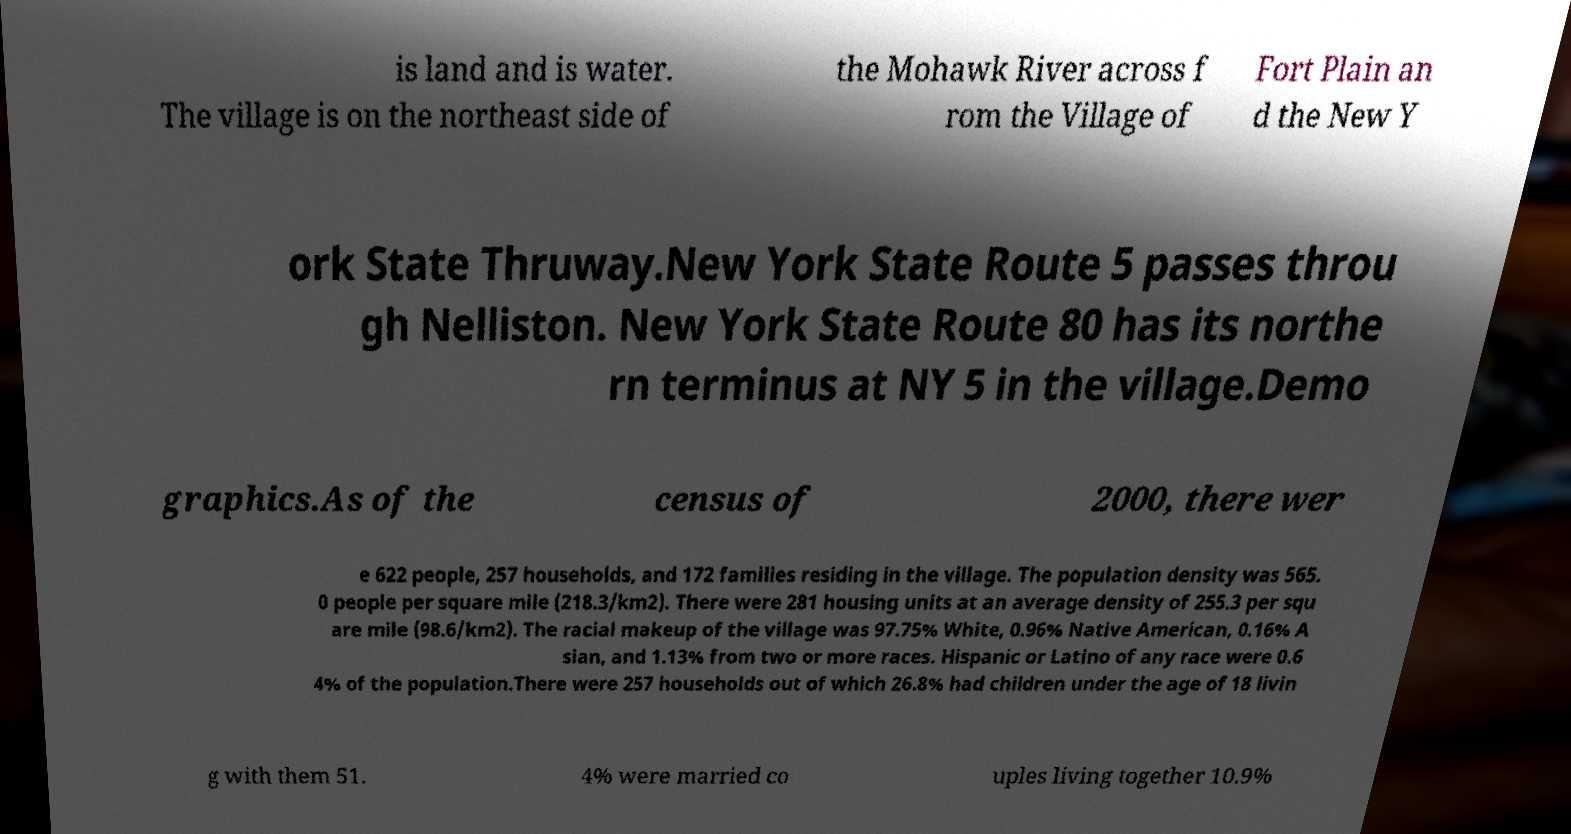Can you accurately transcribe the text from the provided image for me? is land and is water. The village is on the northeast side of the Mohawk River across f rom the Village of Fort Plain an d the New Y ork State Thruway.New York State Route 5 passes throu gh Nelliston. New York State Route 80 has its northe rn terminus at NY 5 in the village.Demo graphics.As of the census of 2000, there wer e 622 people, 257 households, and 172 families residing in the village. The population density was 565. 0 people per square mile (218.3/km2). There were 281 housing units at an average density of 255.3 per squ are mile (98.6/km2). The racial makeup of the village was 97.75% White, 0.96% Native American, 0.16% A sian, and 1.13% from two or more races. Hispanic or Latino of any race were 0.6 4% of the population.There were 257 households out of which 26.8% had children under the age of 18 livin g with them 51. 4% were married co uples living together 10.9% 